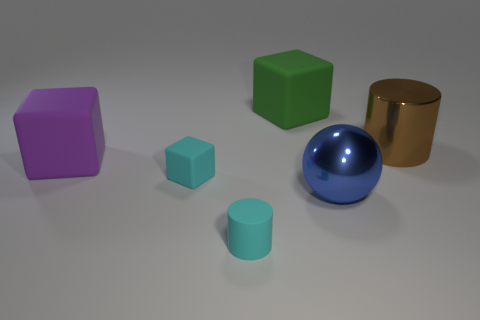There is a small cyan thing that is left of the small object in front of the blue metallic thing; what is it made of?
Make the answer very short. Rubber. There is a cube behind the big rubber block that is in front of the big cube that is behind the purple rubber block; how big is it?
Give a very brief answer. Large. Do the brown metal cylinder and the green thing have the same size?
Your answer should be compact. Yes. Does the cyan thing on the right side of the cyan matte block have the same shape as the big object to the left of the large green object?
Your answer should be very brief. No. Is there a large thing that is behind the small cyan object that is behind the small cyan rubber cylinder?
Make the answer very short. Yes. Are any rubber blocks visible?
Offer a terse response. Yes. What number of other rubber cubes are the same size as the cyan cube?
Provide a succinct answer. 0. What number of objects are on the right side of the green cube and left of the large brown cylinder?
Your answer should be compact. 1. Is the size of the cylinder to the right of the green rubber thing the same as the green rubber thing?
Offer a very short reply. Yes. Is there a ball of the same color as the tiny cube?
Provide a succinct answer. No. 